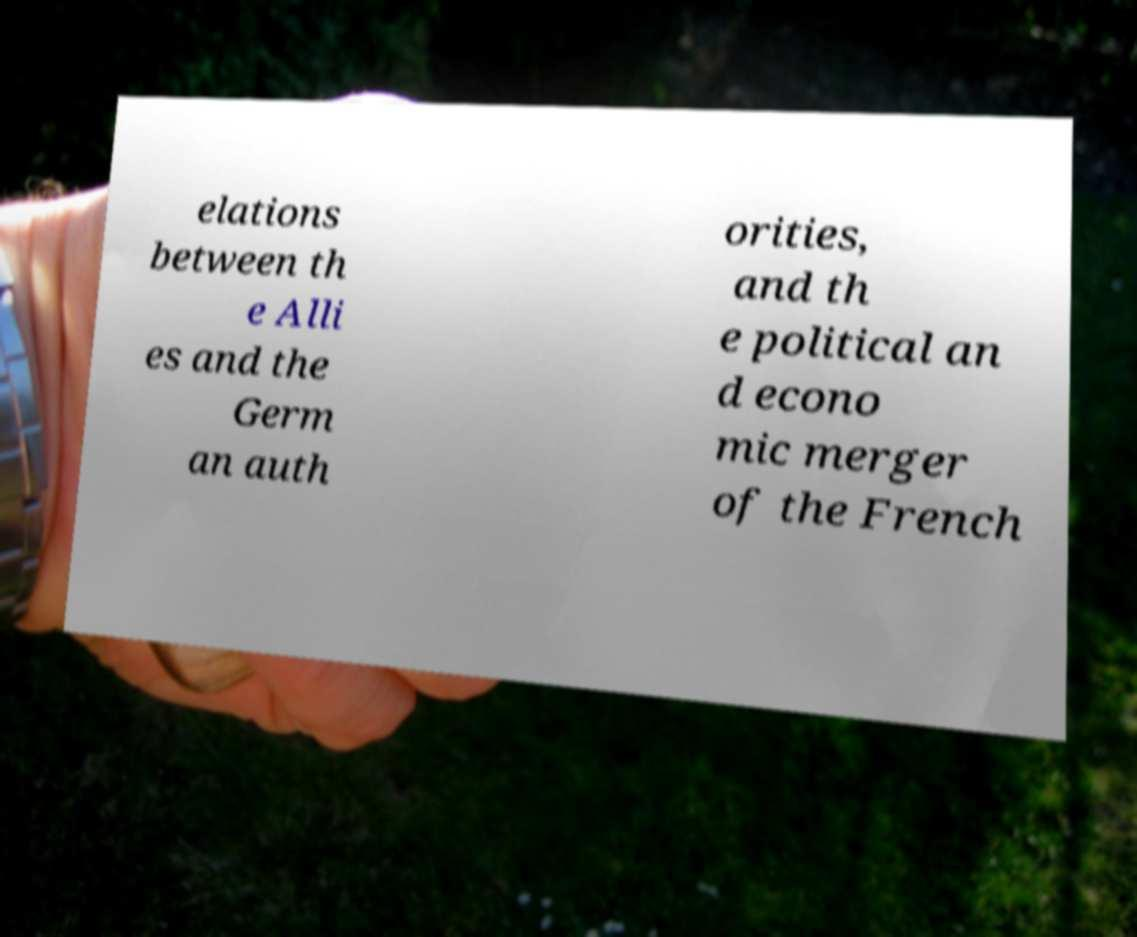Please identify and transcribe the text found in this image. elations between th e Alli es and the Germ an auth orities, and th e political an d econo mic merger of the French 